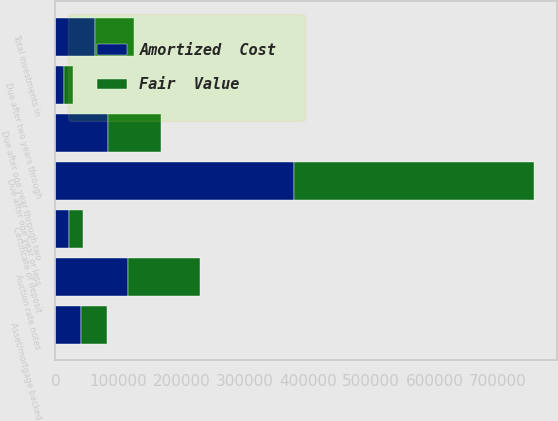<chart> <loc_0><loc_0><loc_500><loc_500><stacked_bar_chart><ecel><fcel>Due after one year or less<fcel>Due after one year through two<fcel>Due after two years through<fcel>Auction rate notes<fcel>Certificate of deposit<fcel>Asset/mortgage backed<fcel>Total investments in<nl><fcel>Fair  Value<fcel>378929<fcel>83333<fcel>14465<fcel>114698<fcel>21866<fcel>40896<fcel>62073.5<nl><fcel>Amortized  Cost<fcel>378105<fcel>83251<fcel>14158<fcel>114698<fcel>21865<fcel>40692<fcel>62073.5<nl></chart> 